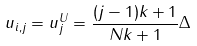<formula> <loc_0><loc_0><loc_500><loc_500>u _ { i , j } = u _ { j } ^ { U } = \frac { ( j - 1 ) k + 1 } { N k + 1 } \Delta \,</formula> 